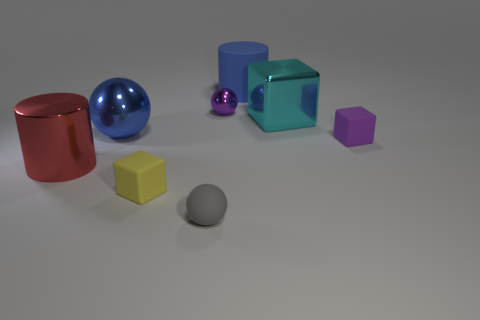Add 2 large things. How many objects exist? 10 Subtract all balls. How many objects are left? 5 Add 7 metallic cubes. How many metallic cubes exist? 8 Subtract 0 yellow cylinders. How many objects are left? 8 Subtract all large brown metallic cylinders. Subtract all red metal things. How many objects are left? 7 Add 1 spheres. How many spheres are left? 4 